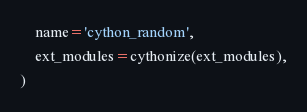<code> <loc_0><loc_0><loc_500><loc_500><_Python_>    name='cython_random',
    ext_modules=cythonize(ext_modules),
)
</code> 